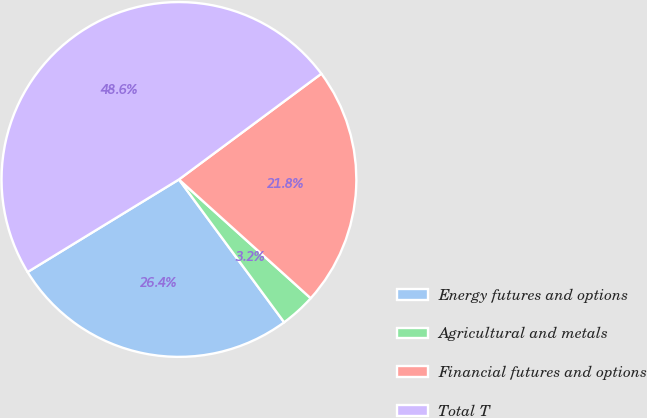<chart> <loc_0><loc_0><loc_500><loc_500><pie_chart><fcel>Energy futures and options<fcel>Agricultural and metals<fcel>Financial futures and options<fcel>Total T<nl><fcel>26.37%<fcel>3.22%<fcel>21.84%<fcel>48.57%<nl></chart> 